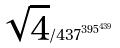<formula> <loc_0><loc_0><loc_500><loc_500>\sqrt { 4 } / 4 3 7 ^ { 3 9 5 ^ { 4 3 9 } }</formula> 